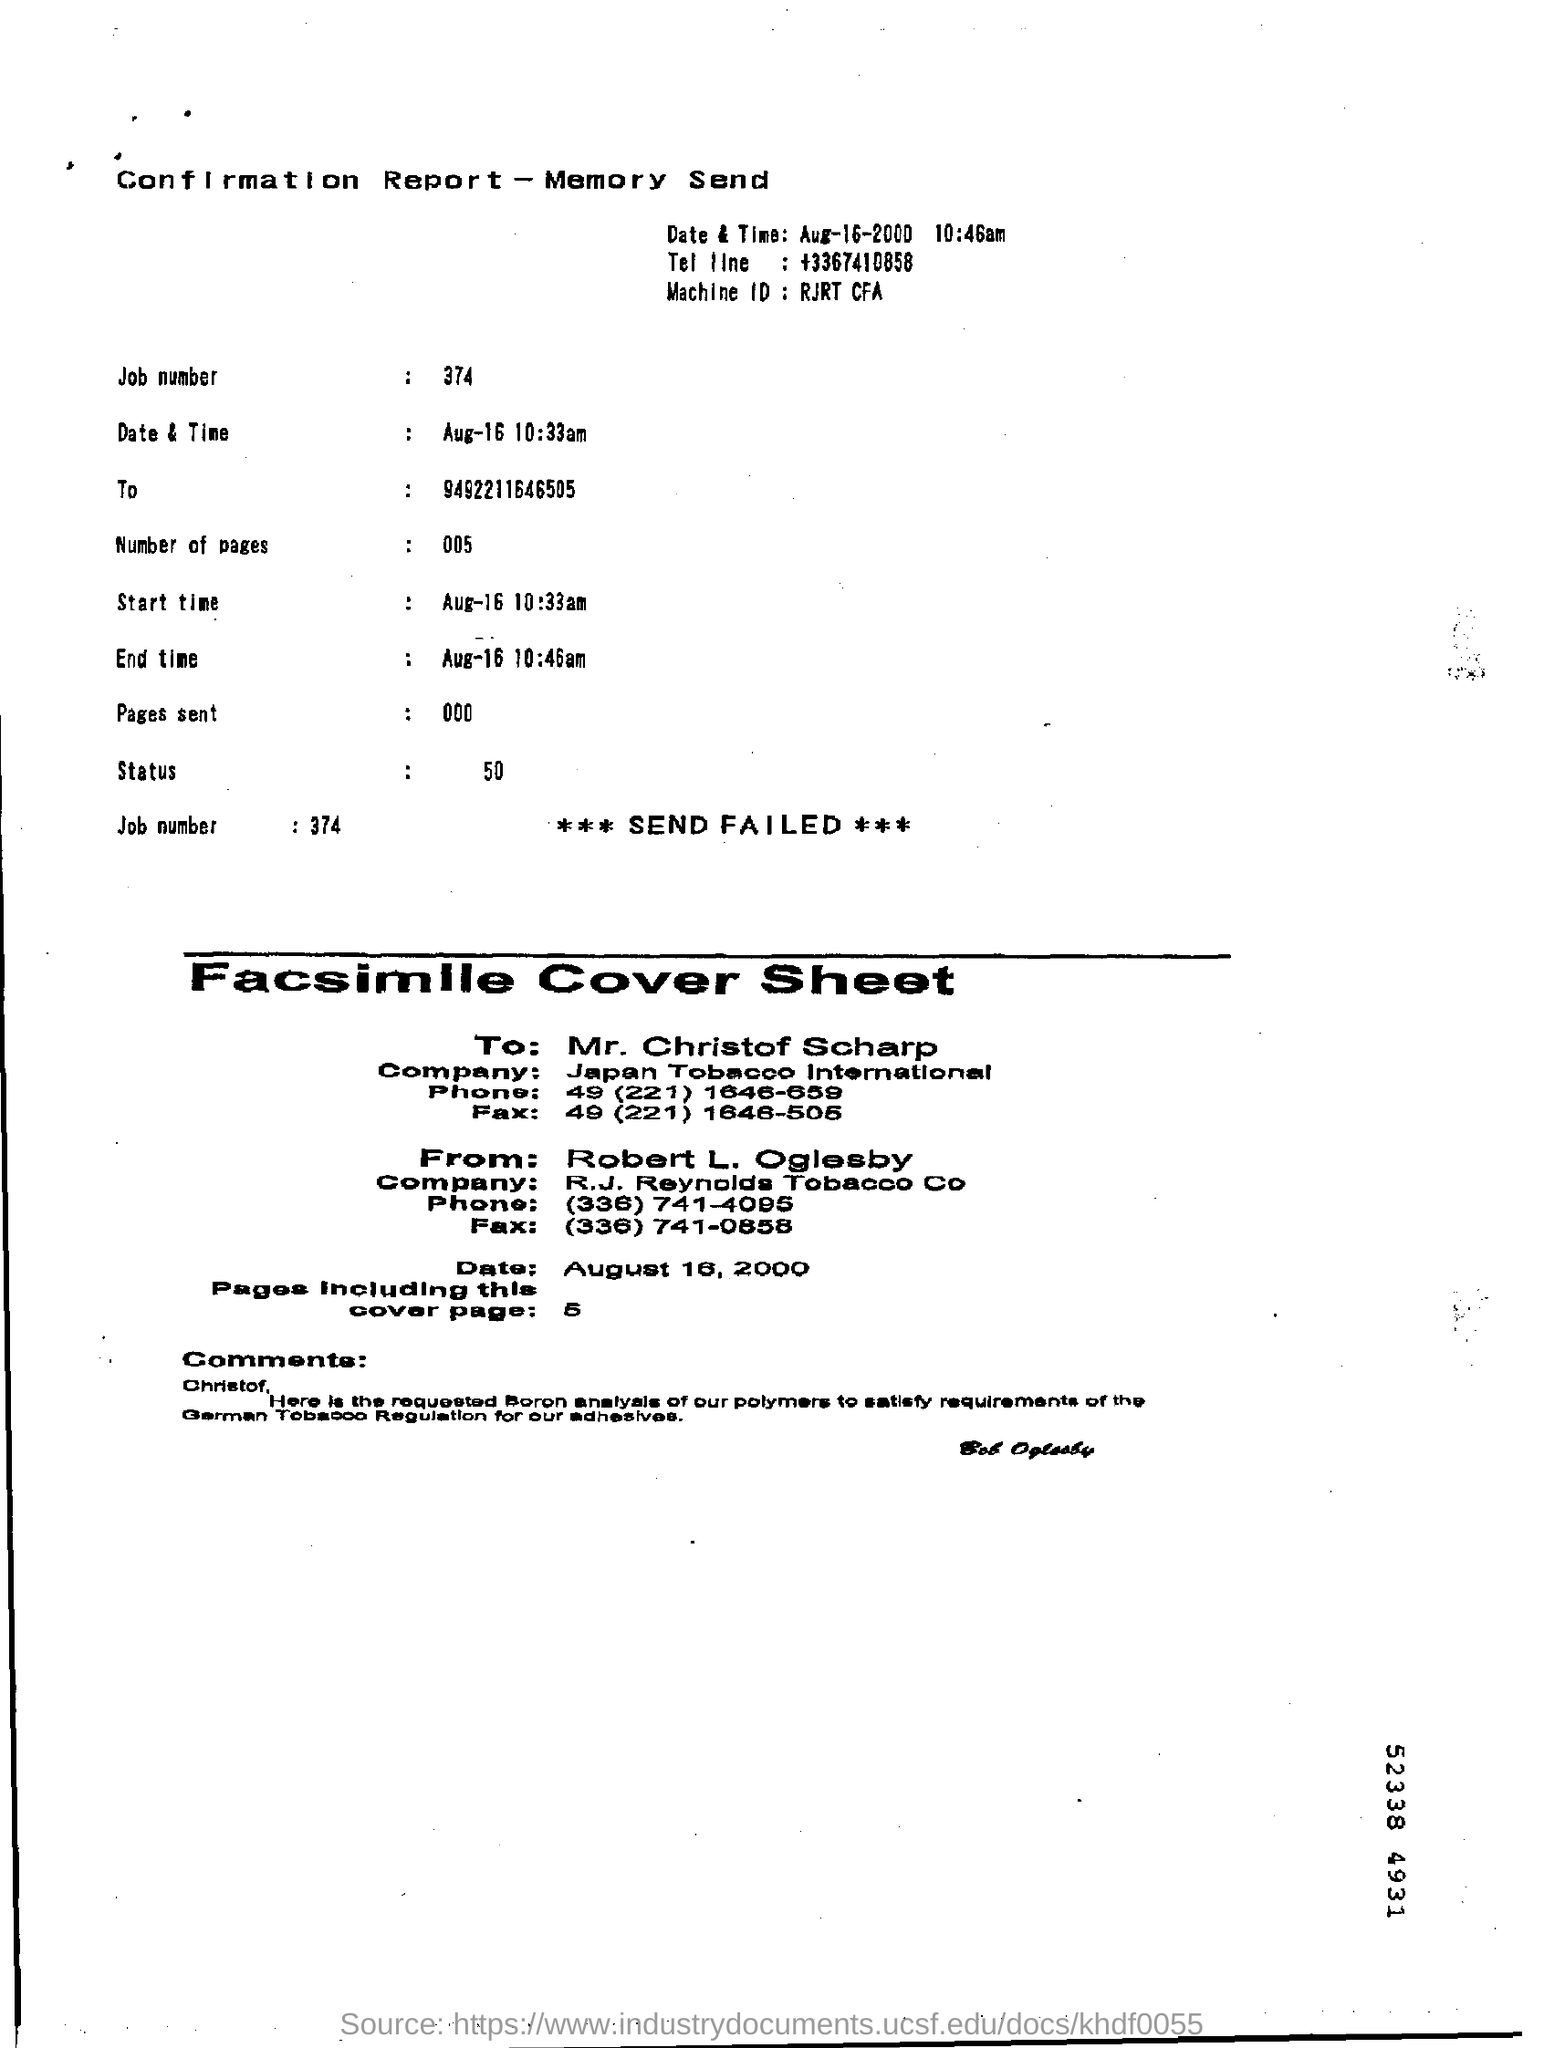What is the job number?
Give a very brief answer. 374. Who is the sender of the facsimile cover sheet?
Make the answer very short. Robert L. Oglesby. What is the company name of the  mr. chirstof scharp?
Your answer should be very brief. Japan Tobacco International. What is the phone number of the mr. chirstof scharp?
Ensure brevity in your answer.  49 (221) 1646-659. 